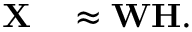<formula> <loc_0><loc_0><loc_500><loc_500>\begin{array} { r l } { X } & \approx W H . } \end{array}</formula> 